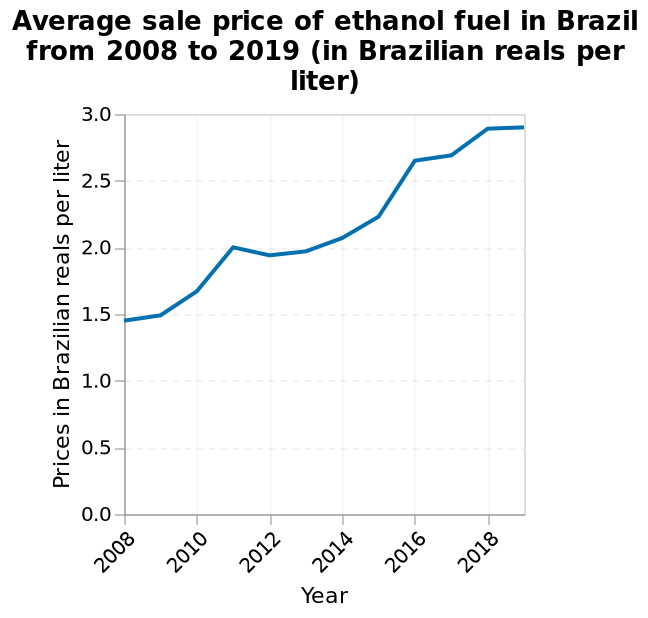<image>
What is the title or figure of the line graph? The title or figure of the line graph is "Average sale price of ethanol fuel in Brazil from 2008 to 2019 (in Brazilian reals per liter)". What is the last year represented on the x-axis of the line graph? The last year represented on the x-axis of the line graph is 2018. 